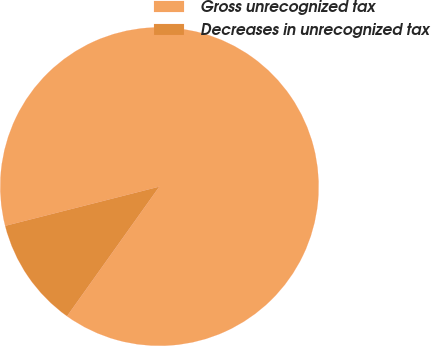Convert chart to OTSL. <chart><loc_0><loc_0><loc_500><loc_500><pie_chart><fcel>Gross unrecognized tax<fcel>Decreases in unrecognized tax<nl><fcel>88.82%<fcel>11.18%<nl></chart> 